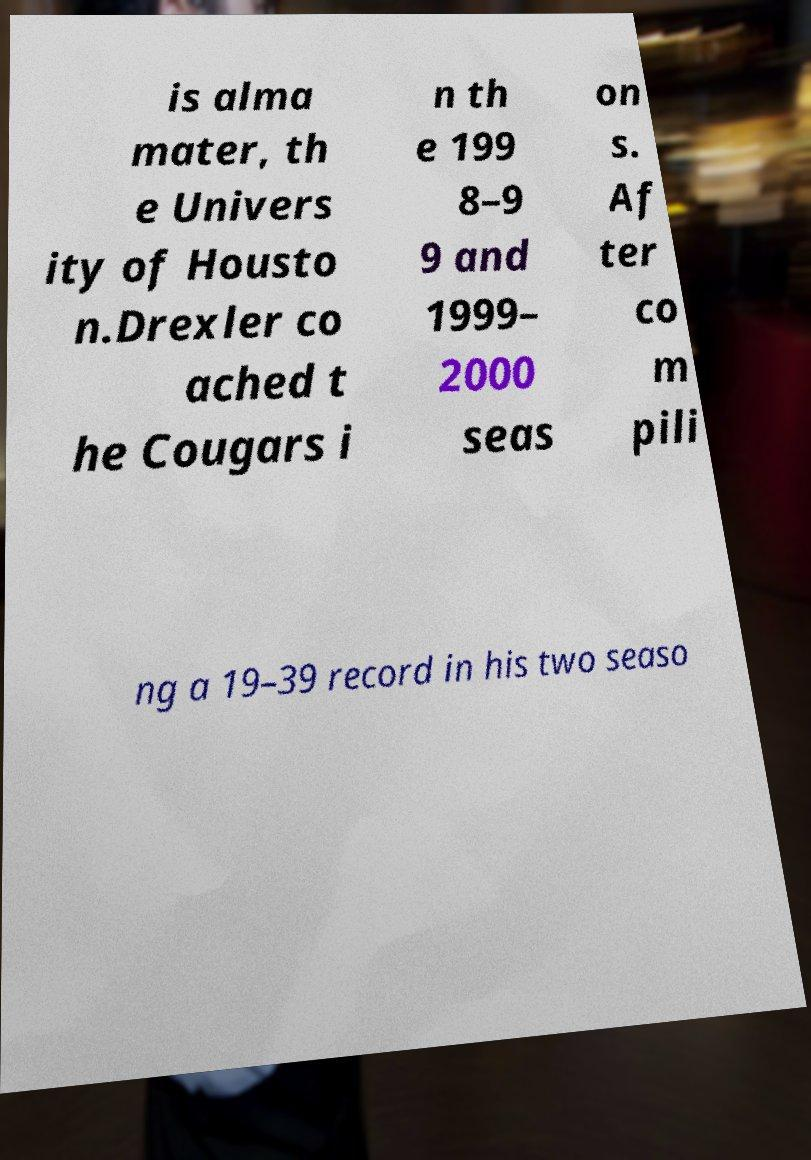Could you assist in decoding the text presented in this image and type it out clearly? is alma mater, th e Univers ity of Housto n.Drexler co ached t he Cougars i n th e 199 8–9 9 and 1999– 2000 seas on s. Af ter co m pili ng a 19–39 record in his two seaso 